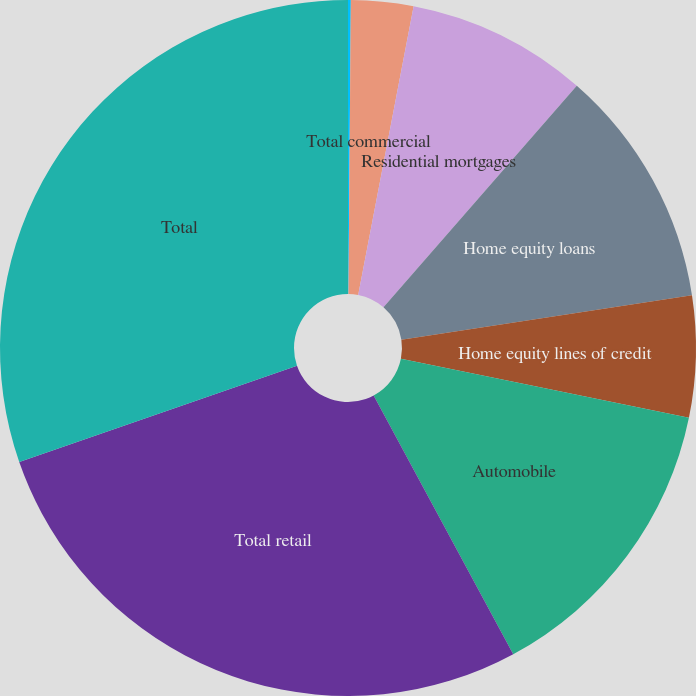Convert chart. <chart><loc_0><loc_0><loc_500><loc_500><pie_chart><fcel>Commercial<fcel>Total commercial<fcel>Residential mortgages<fcel>Home equity loans<fcel>Home equity lines of credit<fcel>Automobile<fcel>Total retail<fcel>Total<nl><fcel>0.13%<fcel>2.89%<fcel>8.4%<fcel>11.16%<fcel>5.64%<fcel>13.91%<fcel>27.56%<fcel>30.32%<nl></chart> 